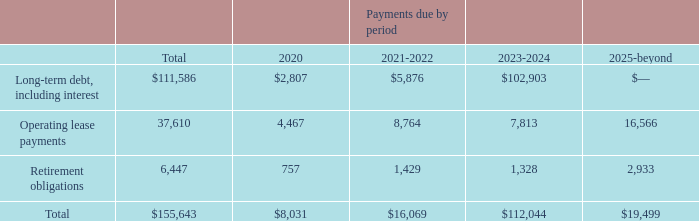Contractual Obligations
Our contractual obligations as of December 31, 2019, were:
We have no off-balance sheet arrangements that have a material current effect or are reasonably likely to have a material future effect on our financial condition or changes in our financial condition.
Management believes that existing capital resources and funds generated from operations are sufficient to finance anticipated capital requirements.
What does the table show? Contractual obligations as of december 31, 2019. What were the Operating lease payments for payments due in 2020? 4,467. What were the total contractual obligations? 155,643. What was the difference between total Operating lease payments and   Retirement obligations  payments ? 37,610-6,447
Answer: 31163. What was the difference between payments due in 2023-2024 between Long-term debt, including interest and  Operating lease payments ? 102,903-7,813
Answer: 95090. What was the percentage change in the total contractual obligations due between 2020 and 2021-2022?
Answer scale should be: percent. (16,069-8,031)/8,031
Answer: 100.09. 